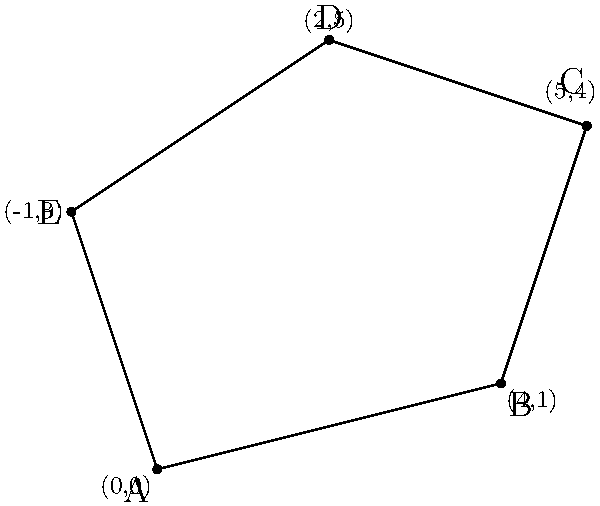As a web developer working with XML and OFBiz, you're tasked with implementing a feature that calculates the perimeter of irregularly shaped plots of land. Given the coordinates of an irregular polygon's vertices as shown in the diagram, calculate its perimeter. Round your answer to two decimal places. To calculate the perimeter of the irregular polygon, we need to sum the distances between consecutive vertices. We can use the distance formula between two points: $d = \sqrt{(x_2-x_1)^2 + (y_2-y_1)^2}$

Let's calculate the distance for each side:

1. Side AB: $d_{AB} = \sqrt{(4-0)^2 + (1-0)^2} = \sqrt{16 + 1} = \sqrt{17}$

2. Side BC: $d_{BC} = \sqrt{(5-4)^2 + (4-1)^2} = \sqrt{1 + 9} = \sqrt{10}$

3. Side CD: $d_{CD} = \sqrt{(2-5)^2 + (5-4)^2} = \sqrt{9 + 1} = \sqrt{10}$

4. Side DE: $d_{DE} = \sqrt{(-1-2)^2 + (3-5)^2} = \sqrt{9 + 4} = \sqrt{13}$

5. Side EA: $d_{EA} = \sqrt{(0-(-1))^2 + (0-3)^2} = \sqrt{1 + 9} = \sqrt{10}$

Now, sum all the distances:

$\text{Perimeter} = \sqrt{17} + \sqrt{10} + \sqrt{10} + \sqrt{13} + \sqrt{10}$

$= 4.12 + 3.16 + 3.16 + 3.61 + 3.16$

$= 17.21$

Rounded to two decimal places, the perimeter is 17.21 units.
Answer: 17.21 units 